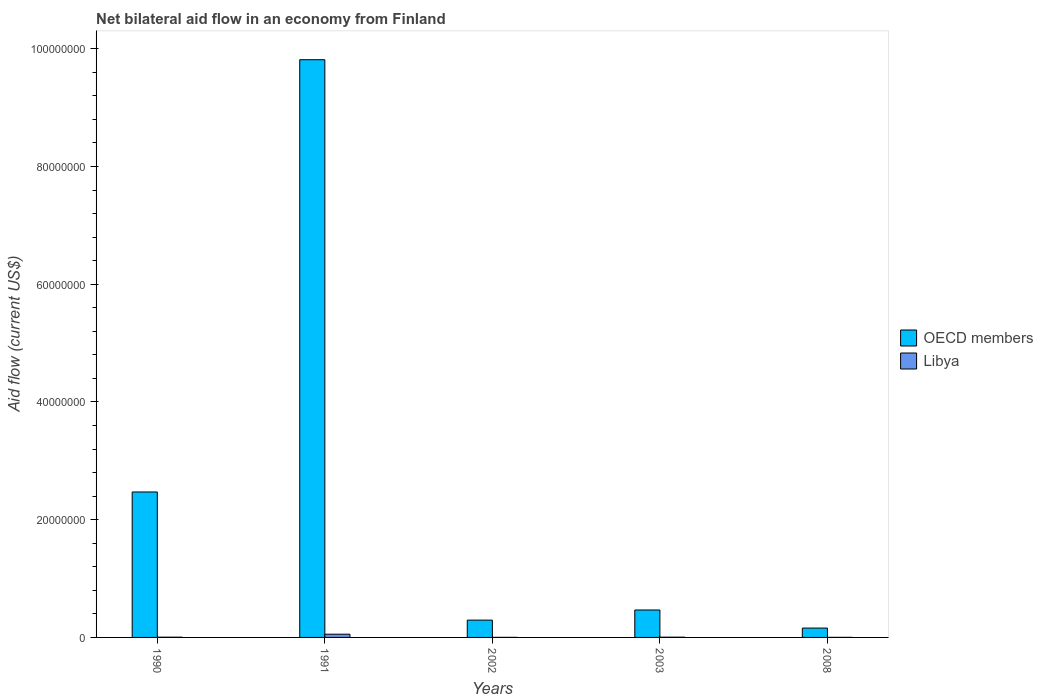How many different coloured bars are there?
Offer a terse response. 2. Are the number of bars per tick equal to the number of legend labels?
Offer a terse response. Yes. Are the number of bars on each tick of the X-axis equal?
Give a very brief answer. Yes. How many bars are there on the 4th tick from the left?
Your response must be concise. 2. What is the label of the 4th group of bars from the left?
Provide a short and direct response. 2003. In how many cases, is the number of bars for a given year not equal to the number of legend labels?
Offer a very short reply. 0. What is the net bilateral aid flow in OECD members in 1991?
Make the answer very short. 9.82e+07. Across all years, what is the maximum net bilateral aid flow in OECD members?
Your answer should be compact. 9.82e+07. Across all years, what is the minimum net bilateral aid flow in OECD members?
Ensure brevity in your answer.  1.59e+06. In which year was the net bilateral aid flow in Libya maximum?
Provide a short and direct response. 1991. In which year was the net bilateral aid flow in OECD members minimum?
Your response must be concise. 2008. What is the total net bilateral aid flow in Libya in the graph?
Offer a very short reply. 6.50e+05. What is the difference between the net bilateral aid flow in OECD members in 2003 and that in 2008?
Ensure brevity in your answer.  3.07e+06. What is the difference between the net bilateral aid flow in Libya in 2002 and the net bilateral aid flow in OECD members in 1990?
Make the answer very short. -2.47e+07. What is the average net bilateral aid flow in OECD members per year?
Ensure brevity in your answer.  2.64e+07. In the year 1990, what is the difference between the net bilateral aid flow in Libya and net bilateral aid flow in OECD members?
Provide a succinct answer. -2.47e+07. In how many years, is the net bilateral aid flow in OECD members greater than 56000000 US$?
Ensure brevity in your answer.  1. What is the ratio of the net bilateral aid flow in OECD members in 2002 to that in 2008?
Your answer should be very brief. 1.85. Is the net bilateral aid flow in OECD members in 1990 less than that in 2002?
Offer a terse response. No. Is the difference between the net bilateral aid flow in Libya in 2003 and 2008 greater than the difference between the net bilateral aid flow in OECD members in 2003 and 2008?
Your answer should be very brief. No. What is the difference between the highest and the second highest net bilateral aid flow in Libya?
Give a very brief answer. 5.10e+05. What is the difference between the highest and the lowest net bilateral aid flow in Libya?
Your response must be concise. 5.40e+05. What does the 1st bar from the left in 1990 represents?
Your response must be concise. OECD members. What does the 1st bar from the right in 2008 represents?
Your answer should be very brief. Libya. Are all the bars in the graph horizontal?
Ensure brevity in your answer.  No. How many years are there in the graph?
Offer a very short reply. 5. Does the graph contain any zero values?
Your answer should be compact. No. Where does the legend appear in the graph?
Ensure brevity in your answer.  Center right. How many legend labels are there?
Provide a succinct answer. 2. What is the title of the graph?
Give a very brief answer. Net bilateral aid flow in an economy from Finland. What is the label or title of the X-axis?
Make the answer very short. Years. What is the label or title of the Y-axis?
Give a very brief answer. Aid flow (current US$). What is the Aid flow (current US$) of OECD members in 1990?
Your answer should be compact. 2.47e+07. What is the Aid flow (current US$) of OECD members in 1991?
Offer a very short reply. 9.82e+07. What is the Aid flow (current US$) in Libya in 1991?
Provide a short and direct response. 5.50e+05. What is the Aid flow (current US$) of OECD members in 2002?
Provide a short and direct response. 2.94e+06. What is the Aid flow (current US$) in OECD members in 2003?
Your response must be concise. 4.66e+06. What is the Aid flow (current US$) in OECD members in 2008?
Ensure brevity in your answer.  1.59e+06. What is the Aid flow (current US$) in Libya in 2008?
Make the answer very short. 10000. Across all years, what is the maximum Aid flow (current US$) in OECD members?
Your answer should be very brief. 9.82e+07. Across all years, what is the minimum Aid flow (current US$) of OECD members?
Your answer should be very brief. 1.59e+06. What is the total Aid flow (current US$) of OECD members in the graph?
Provide a short and direct response. 1.32e+08. What is the total Aid flow (current US$) of Libya in the graph?
Offer a terse response. 6.50e+05. What is the difference between the Aid flow (current US$) of OECD members in 1990 and that in 1991?
Provide a succinct answer. -7.34e+07. What is the difference between the Aid flow (current US$) of Libya in 1990 and that in 1991?
Keep it short and to the point. -5.10e+05. What is the difference between the Aid flow (current US$) of OECD members in 1990 and that in 2002?
Make the answer very short. 2.18e+07. What is the difference between the Aid flow (current US$) in Libya in 1990 and that in 2002?
Your answer should be very brief. 3.00e+04. What is the difference between the Aid flow (current US$) in OECD members in 1990 and that in 2003?
Your answer should be compact. 2.00e+07. What is the difference between the Aid flow (current US$) of Libya in 1990 and that in 2003?
Keep it short and to the point. 0. What is the difference between the Aid flow (current US$) in OECD members in 1990 and that in 2008?
Offer a terse response. 2.31e+07. What is the difference between the Aid flow (current US$) in Libya in 1990 and that in 2008?
Provide a short and direct response. 3.00e+04. What is the difference between the Aid flow (current US$) in OECD members in 1991 and that in 2002?
Keep it short and to the point. 9.52e+07. What is the difference between the Aid flow (current US$) in Libya in 1991 and that in 2002?
Ensure brevity in your answer.  5.40e+05. What is the difference between the Aid flow (current US$) in OECD members in 1991 and that in 2003?
Your answer should be very brief. 9.35e+07. What is the difference between the Aid flow (current US$) in Libya in 1991 and that in 2003?
Provide a succinct answer. 5.10e+05. What is the difference between the Aid flow (current US$) in OECD members in 1991 and that in 2008?
Your response must be concise. 9.66e+07. What is the difference between the Aid flow (current US$) in Libya in 1991 and that in 2008?
Provide a succinct answer. 5.40e+05. What is the difference between the Aid flow (current US$) in OECD members in 2002 and that in 2003?
Offer a very short reply. -1.72e+06. What is the difference between the Aid flow (current US$) in Libya in 2002 and that in 2003?
Offer a terse response. -3.00e+04. What is the difference between the Aid flow (current US$) in OECD members in 2002 and that in 2008?
Provide a succinct answer. 1.35e+06. What is the difference between the Aid flow (current US$) in OECD members in 2003 and that in 2008?
Your answer should be very brief. 3.07e+06. What is the difference between the Aid flow (current US$) in Libya in 2003 and that in 2008?
Provide a succinct answer. 3.00e+04. What is the difference between the Aid flow (current US$) in OECD members in 1990 and the Aid flow (current US$) in Libya in 1991?
Keep it short and to the point. 2.42e+07. What is the difference between the Aid flow (current US$) in OECD members in 1990 and the Aid flow (current US$) in Libya in 2002?
Your response must be concise. 2.47e+07. What is the difference between the Aid flow (current US$) of OECD members in 1990 and the Aid flow (current US$) of Libya in 2003?
Offer a very short reply. 2.47e+07. What is the difference between the Aid flow (current US$) of OECD members in 1990 and the Aid flow (current US$) of Libya in 2008?
Ensure brevity in your answer.  2.47e+07. What is the difference between the Aid flow (current US$) of OECD members in 1991 and the Aid flow (current US$) of Libya in 2002?
Offer a very short reply. 9.81e+07. What is the difference between the Aid flow (current US$) in OECD members in 1991 and the Aid flow (current US$) in Libya in 2003?
Offer a very short reply. 9.81e+07. What is the difference between the Aid flow (current US$) of OECD members in 1991 and the Aid flow (current US$) of Libya in 2008?
Provide a short and direct response. 9.81e+07. What is the difference between the Aid flow (current US$) in OECD members in 2002 and the Aid flow (current US$) in Libya in 2003?
Provide a succinct answer. 2.90e+06. What is the difference between the Aid flow (current US$) in OECD members in 2002 and the Aid flow (current US$) in Libya in 2008?
Offer a very short reply. 2.93e+06. What is the difference between the Aid flow (current US$) of OECD members in 2003 and the Aid flow (current US$) of Libya in 2008?
Make the answer very short. 4.65e+06. What is the average Aid flow (current US$) of OECD members per year?
Make the answer very short. 2.64e+07. In the year 1990, what is the difference between the Aid flow (current US$) of OECD members and Aid flow (current US$) of Libya?
Offer a very short reply. 2.47e+07. In the year 1991, what is the difference between the Aid flow (current US$) of OECD members and Aid flow (current US$) of Libya?
Your response must be concise. 9.76e+07. In the year 2002, what is the difference between the Aid flow (current US$) of OECD members and Aid flow (current US$) of Libya?
Your answer should be very brief. 2.93e+06. In the year 2003, what is the difference between the Aid flow (current US$) in OECD members and Aid flow (current US$) in Libya?
Your response must be concise. 4.62e+06. In the year 2008, what is the difference between the Aid flow (current US$) in OECD members and Aid flow (current US$) in Libya?
Make the answer very short. 1.58e+06. What is the ratio of the Aid flow (current US$) in OECD members in 1990 to that in 1991?
Provide a short and direct response. 0.25. What is the ratio of the Aid flow (current US$) in Libya in 1990 to that in 1991?
Provide a succinct answer. 0.07. What is the ratio of the Aid flow (current US$) of OECD members in 1990 to that in 2002?
Your answer should be very brief. 8.4. What is the ratio of the Aid flow (current US$) in Libya in 1990 to that in 2002?
Provide a succinct answer. 4. What is the ratio of the Aid flow (current US$) of OECD members in 1990 to that in 2003?
Your answer should be compact. 5.3. What is the ratio of the Aid flow (current US$) in OECD members in 1990 to that in 2008?
Make the answer very short. 15.54. What is the ratio of the Aid flow (current US$) in OECD members in 1991 to that in 2002?
Your answer should be compact. 33.38. What is the ratio of the Aid flow (current US$) in Libya in 1991 to that in 2002?
Your response must be concise. 55. What is the ratio of the Aid flow (current US$) of OECD members in 1991 to that in 2003?
Your response must be concise. 21.06. What is the ratio of the Aid flow (current US$) in Libya in 1991 to that in 2003?
Ensure brevity in your answer.  13.75. What is the ratio of the Aid flow (current US$) of OECD members in 1991 to that in 2008?
Provide a short and direct response. 61.73. What is the ratio of the Aid flow (current US$) in OECD members in 2002 to that in 2003?
Make the answer very short. 0.63. What is the ratio of the Aid flow (current US$) in OECD members in 2002 to that in 2008?
Your answer should be compact. 1.85. What is the ratio of the Aid flow (current US$) of Libya in 2002 to that in 2008?
Make the answer very short. 1. What is the ratio of the Aid flow (current US$) of OECD members in 2003 to that in 2008?
Provide a short and direct response. 2.93. What is the difference between the highest and the second highest Aid flow (current US$) of OECD members?
Provide a succinct answer. 7.34e+07. What is the difference between the highest and the second highest Aid flow (current US$) of Libya?
Make the answer very short. 5.10e+05. What is the difference between the highest and the lowest Aid flow (current US$) of OECD members?
Provide a short and direct response. 9.66e+07. What is the difference between the highest and the lowest Aid flow (current US$) in Libya?
Offer a very short reply. 5.40e+05. 